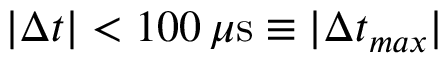<formula> <loc_0><loc_0><loc_500><loc_500>| \Delta t | < 1 0 0 \, \mu s \equiv | \Delta t _ { \max } |</formula> 